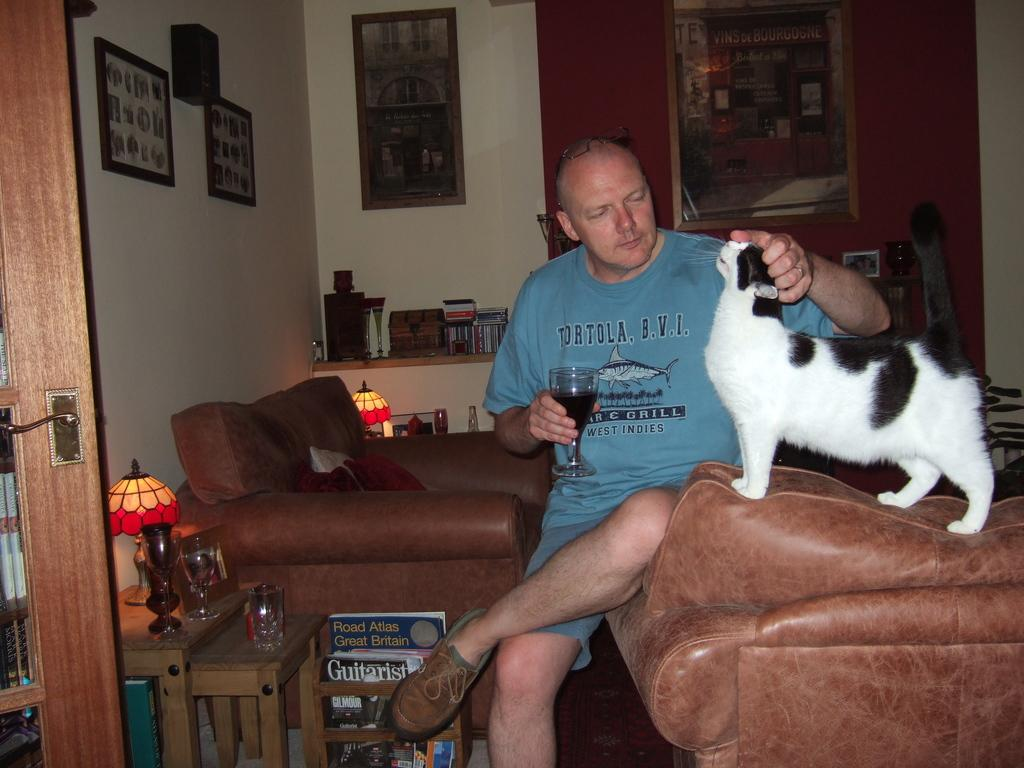<image>
Present a compact description of the photo's key features. A man wearing a Tortola, B.V.I. shirt pets a cat 